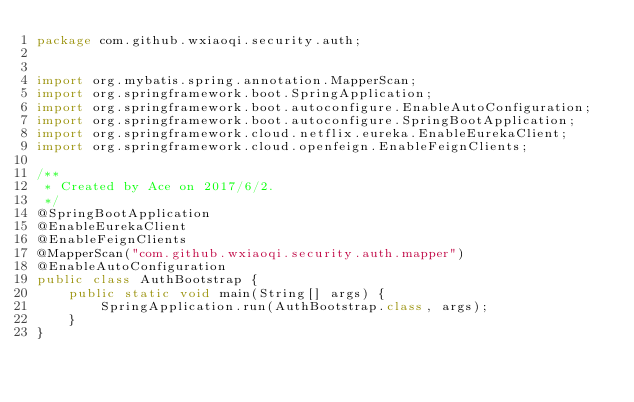Convert code to text. <code><loc_0><loc_0><loc_500><loc_500><_Java_>package com.github.wxiaoqi.security.auth;


import org.mybatis.spring.annotation.MapperScan;
import org.springframework.boot.SpringApplication;
import org.springframework.boot.autoconfigure.EnableAutoConfiguration;
import org.springframework.boot.autoconfigure.SpringBootApplication;
import org.springframework.cloud.netflix.eureka.EnableEurekaClient;
import org.springframework.cloud.openfeign.EnableFeignClients;

/**
 * Created by Ace on 2017/6/2.
 */
@SpringBootApplication
@EnableEurekaClient
@EnableFeignClients
@MapperScan("com.github.wxiaoqi.security.auth.mapper")
@EnableAutoConfiguration
public class AuthBootstrap {
    public static void main(String[] args) {
        SpringApplication.run(AuthBootstrap.class, args);
    }
}
</code> 